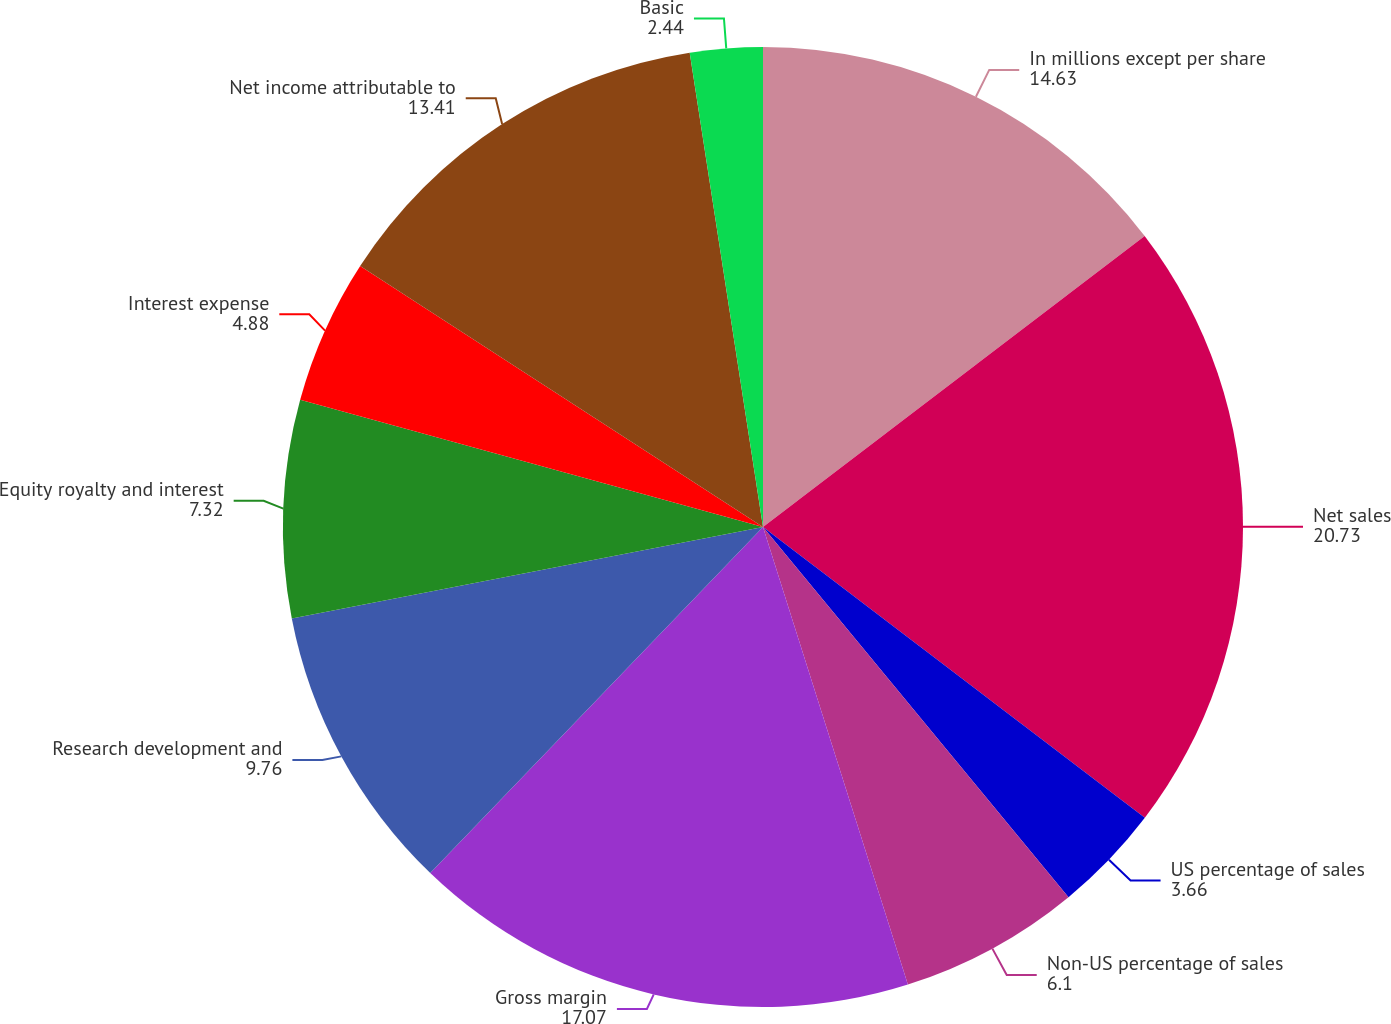<chart> <loc_0><loc_0><loc_500><loc_500><pie_chart><fcel>In millions except per share<fcel>Net sales<fcel>US percentage of sales<fcel>Non-US percentage of sales<fcel>Gross margin<fcel>Research development and<fcel>Equity royalty and interest<fcel>Interest expense<fcel>Net income attributable to<fcel>Basic<nl><fcel>14.63%<fcel>20.73%<fcel>3.66%<fcel>6.1%<fcel>17.07%<fcel>9.76%<fcel>7.32%<fcel>4.88%<fcel>13.41%<fcel>2.44%<nl></chart> 